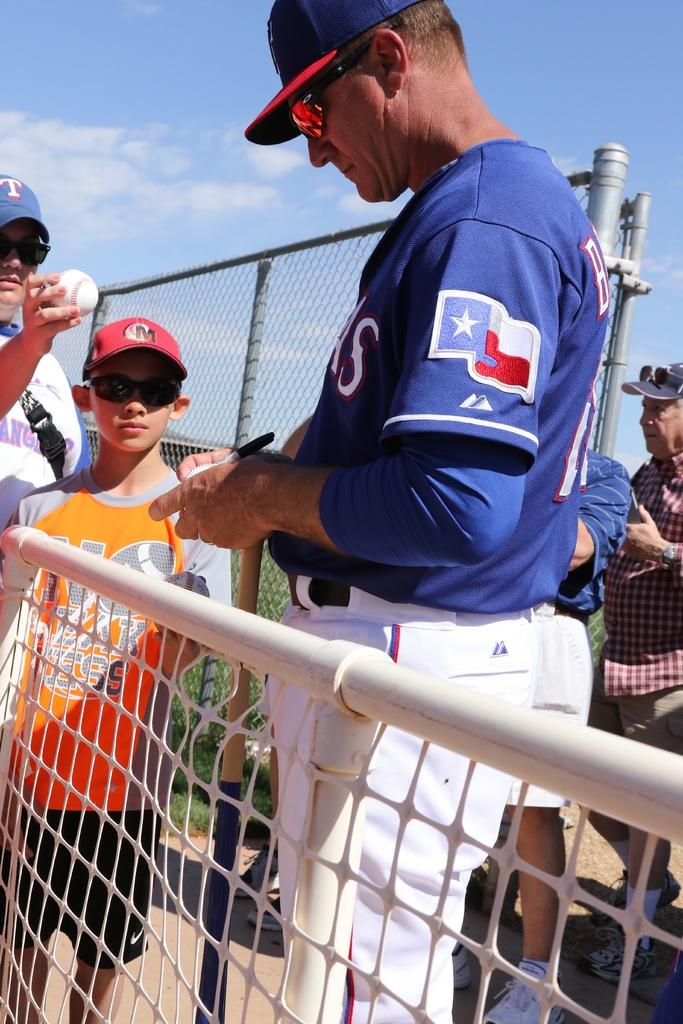Who or what is present in the image? There are people in the image. What are the people holding in the image? The people are holding balls. What are the people wearing in the image? The people are wearing caps. What type of architectural features can be seen in the image? There is an iron gate and a fence in the image. What is the color of the sky in the image? The sky is blue in the image. What type of string is being used by the grandfather in the image? There is no grandfather or string present in the image. 